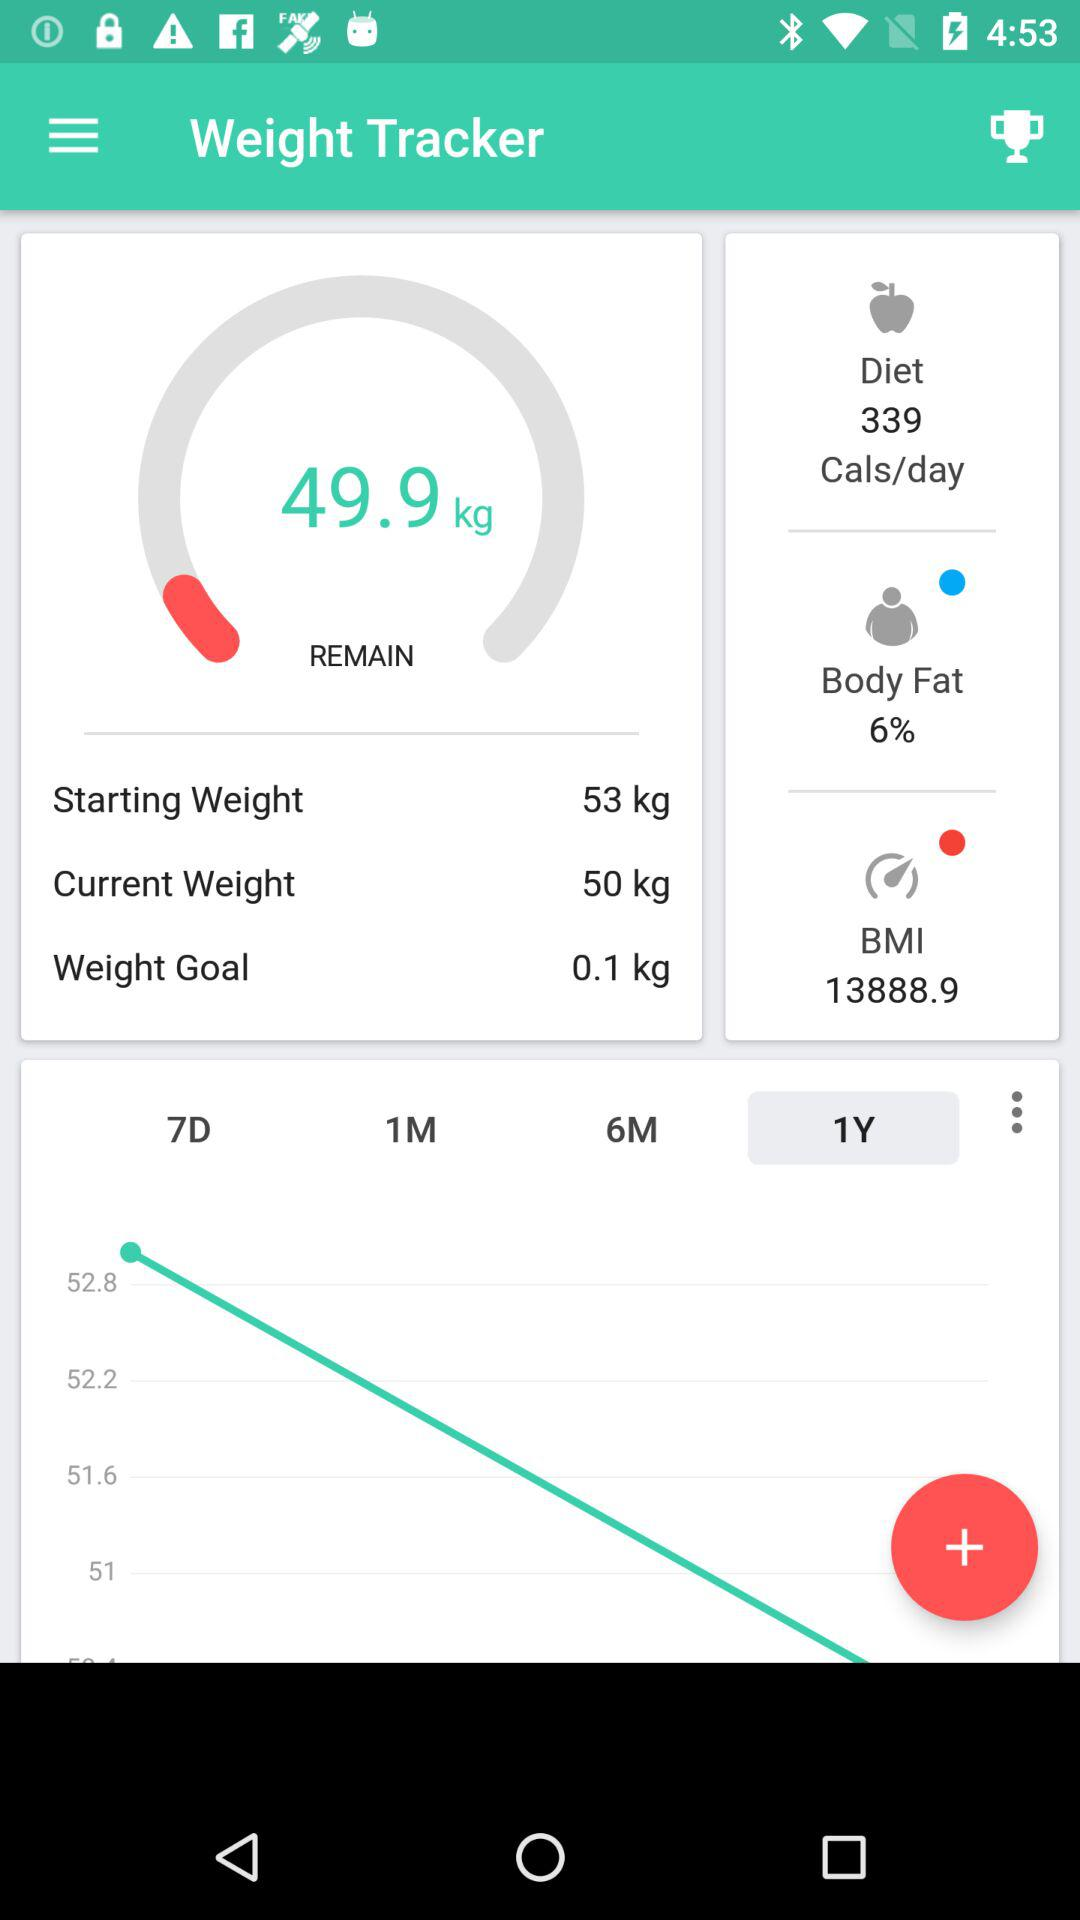What is the starting weight? The starting weight is 53 kilograms. 